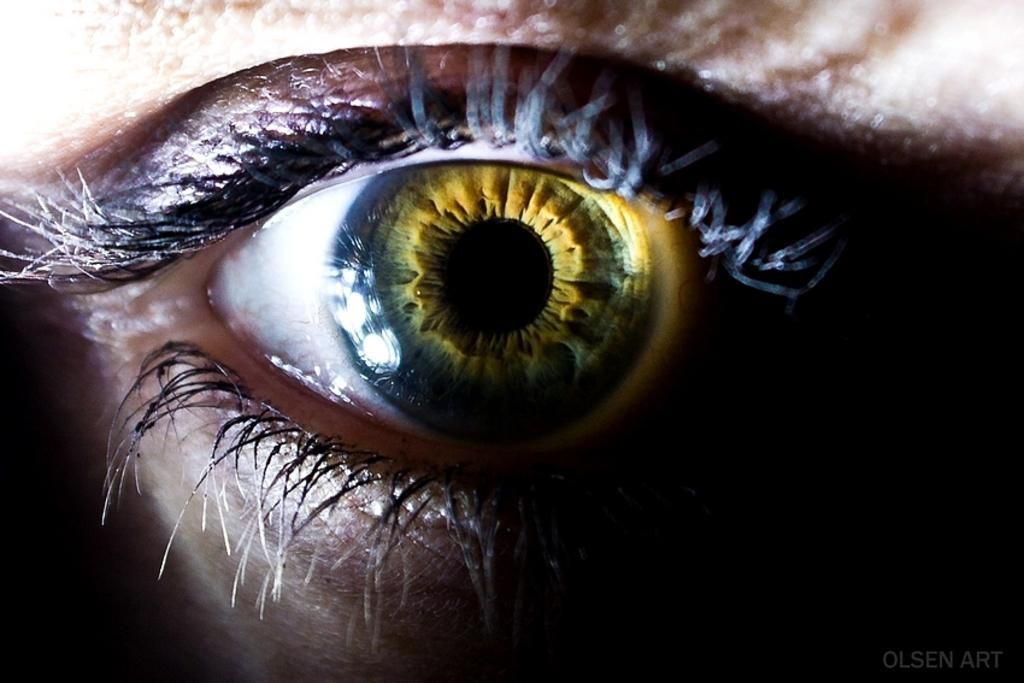What is the main subject of the image? The main subject of the image is a human eye. Can you describe the colors present in the human eye? The human eye has black, white, and yellow colors. What time of day is depicted in the image? The image does not depict a specific time of day, as it only features a human eye. What type of brass object can be seen in the image? There is no brass object present in the image; it only features a human eye. 